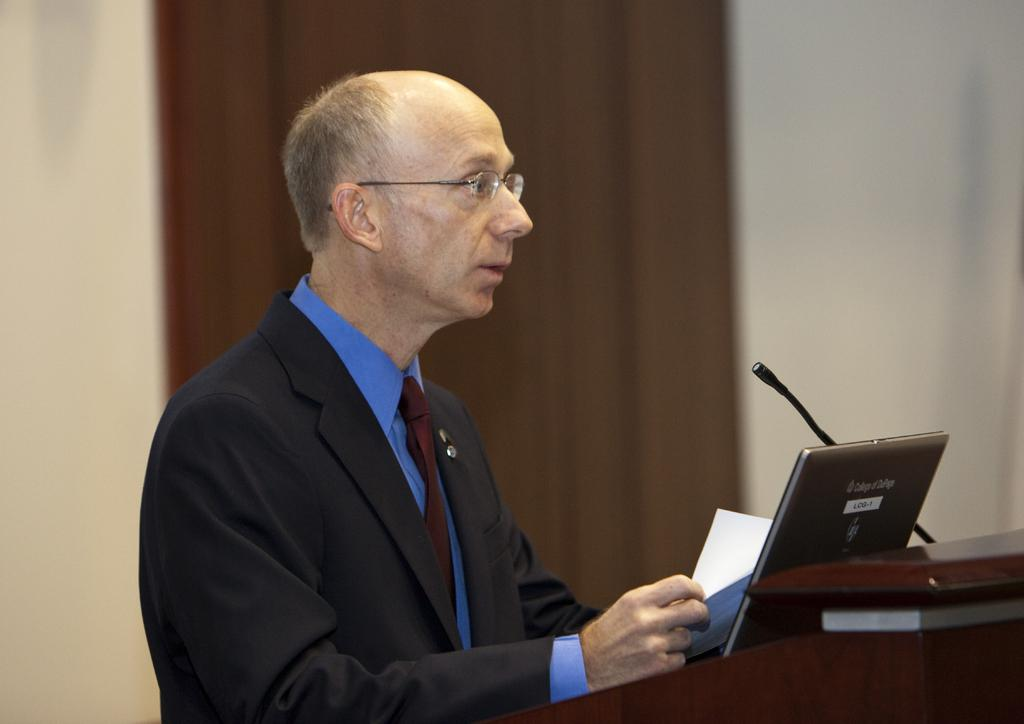Who is the main subject in the picture? There is an old man in the picture. What is the old man wearing? The old man is wearing a black suit. What is the old man doing in the picture? The old man is giving a speech. What object does the old man have with him? The old man has a laptop with him. What can be seen in the background of the picture? There is a brown curtain and a wall in the background. What type of ice can be seen melting on the speech desk in the image? There is no ice present in the image; it features an old man giving a speech at a desk with a laptop. 